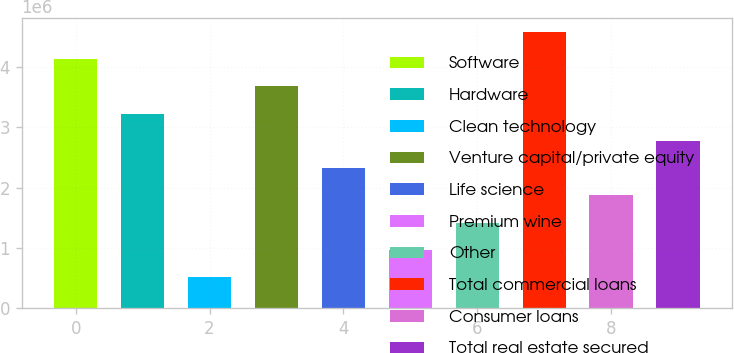Convert chart. <chart><loc_0><loc_0><loc_500><loc_500><bar_chart><fcel>Software<fcel>Hardware<fcel>Clean technology<fcel>Venture capital/private equity<fcel>Life science<fcel>Premium wine<fcel>Other<fcel>Total commercial loans<fcel>Consumer loans<fcel>Total real estate secured<nl><fcel>4.1307e+06<fcel>3.22618e+06<fcel>512599<fcel>3.67844e+06<fcel>2.32165e+06<fcel>964862<fcel>1.41712e+06<fcel>4.58297e+06<fcel>1.86939e+06<fcel>2.77391e+06<nl></chart> 